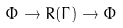<formula> <loc_0><loc_0><loc_500><loc_500>\Phi \to R ( \Gamma ) \to \Phi</formula> 